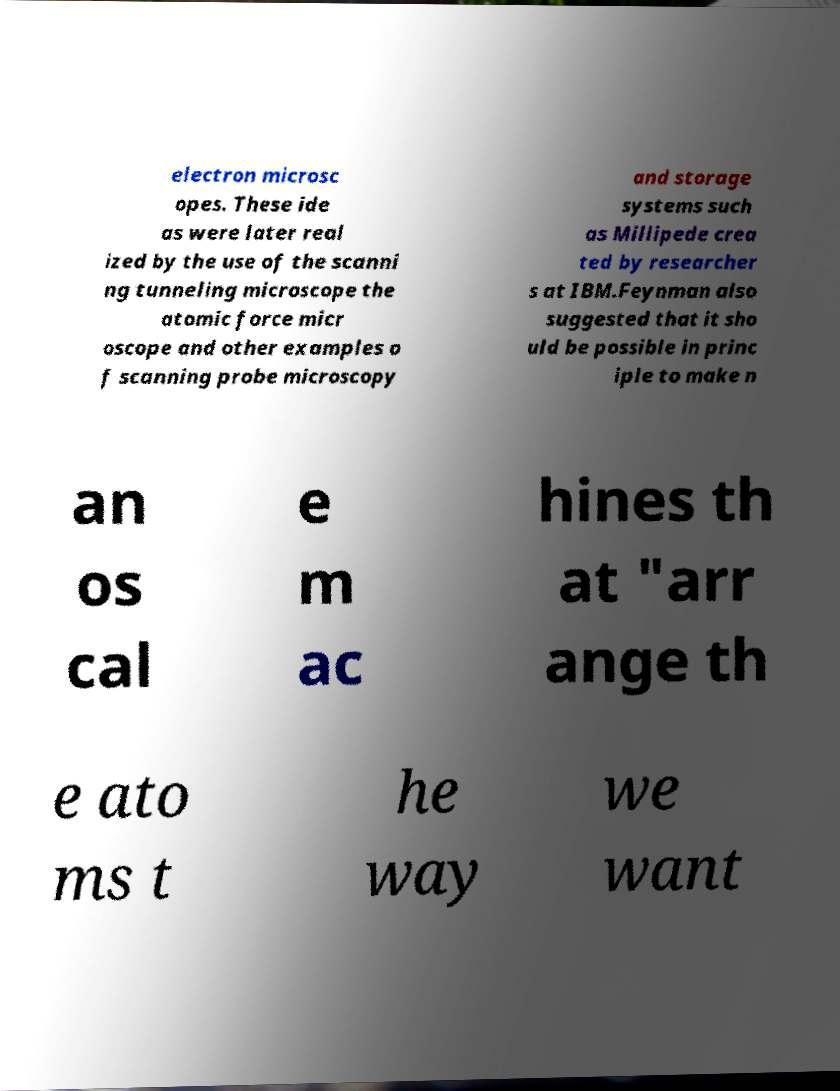Please read and relay the text visible in this image. What does it say? electron microsc opes. These ide as were later real ized by the use of the scanni ng tunneling microscope the atomic force micr oscope and other examples o f scanning probe microscopy and storage systems such as Millipede crea ted by researcher s at IBM.Feynman also suggested that it sho uld be possible in princ iple to make n an os cal e m ac hines th at "arr ange th e ato ms t he way we want 